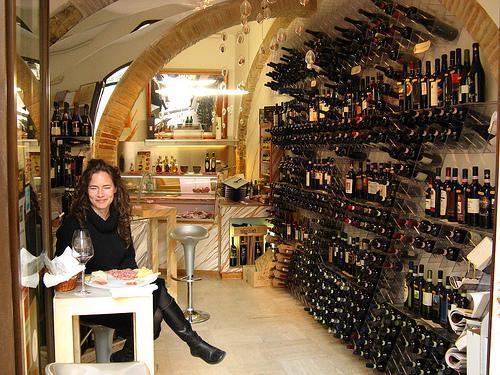How many people are shown?
Give a very brief answer. 1. How many glasses are on the table?
Give a very brief answer. 2. 